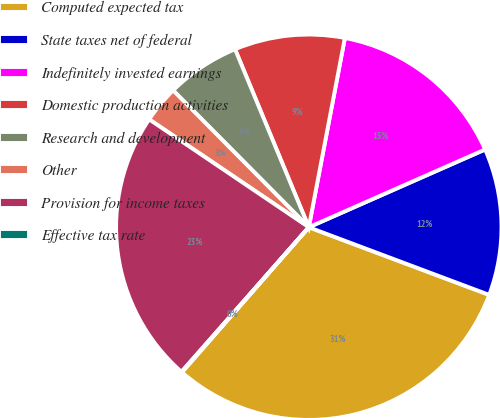<chart> <loc_0><loc_0><loc_500><loc_500><pie_chart><fcel>Computed expected tax<fcel>State taxes net of federal<fcel>Indefinitely invested earnings<fcel>Domestic production activities<fcel>Research and development<fcel>Other<fcel>Provision for income taxes<fcel>Effective tax rate<nl><fcel>30.73%<fcel>12.32%<fcel>15.39%<fcel>9.25%<fcel>6.18%<fcel>3.11%<fcel>22.97%<fcel>0.05%<nl></chart> 